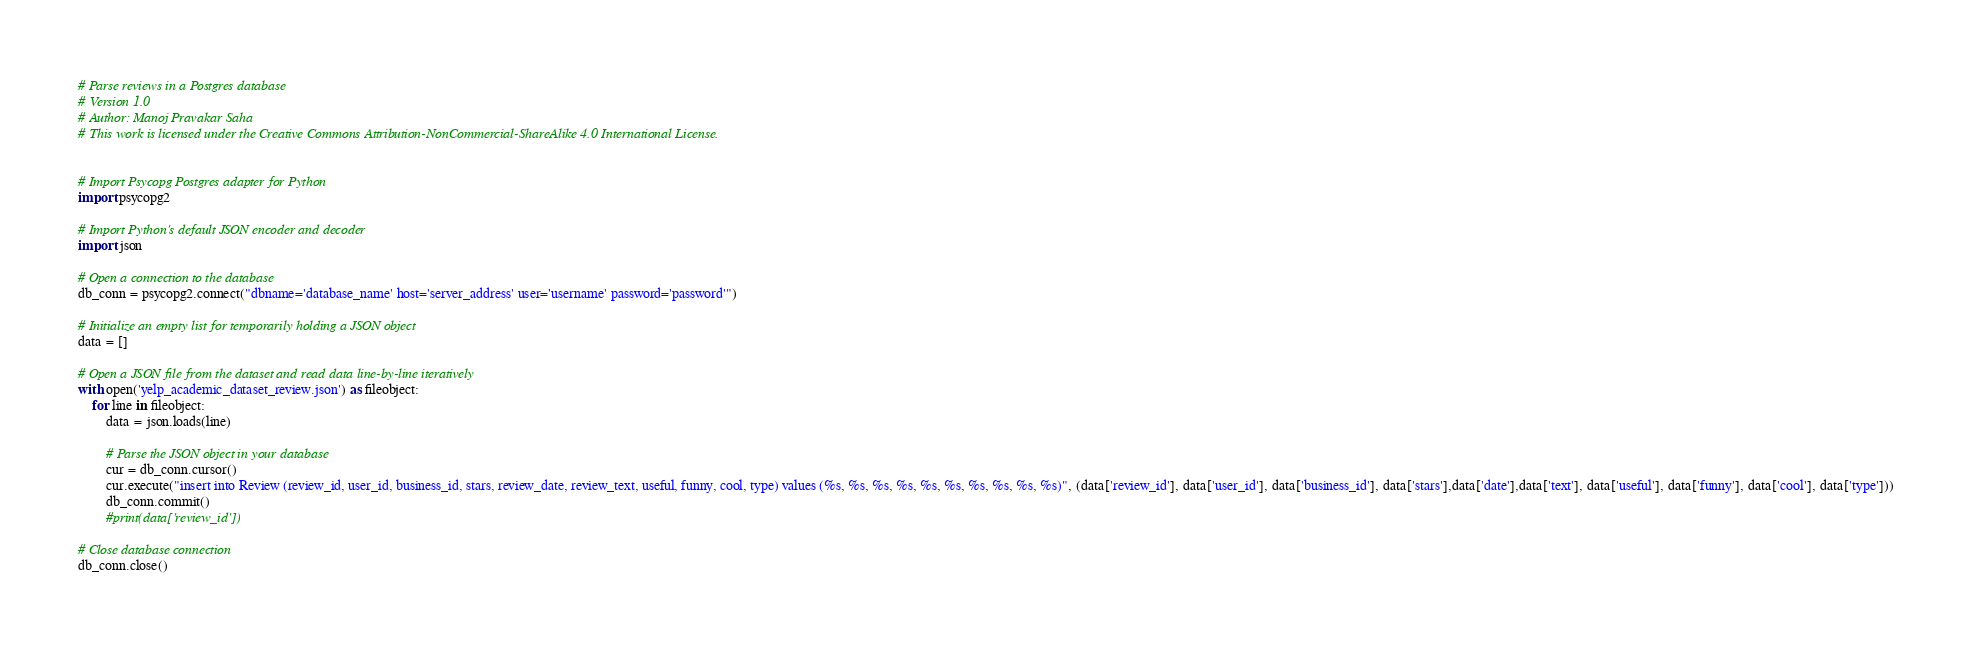<code> <loc_0><loc_0><loc_500><loc_500><_Python_># Parse reviews in a Postgres database
# Version 1.0
# Author: Manoj Pravakar Saha
# This work is licensed under the Creative Commons Attribution-NonCommercial-ShareAlike 4.0 International License.


# Import Psycopg Postgres adapter for Python
import psycopg2

# Import Python's default JSON encoder and decoder
import json

# Open a connection to the database
db_conn = psycopg2.connect("dbname='database_name' host='server_address' user='username' password='password'")

# Initialize an empty list for temporarily holding a JSON object
data = []

# Open a JSON file from the dataset and read data line-by-line iteratively
with open('yelp_academic_dataset_review.json') as fileobject:
	for line in fileobject:
		data = json.loads(line)

		# Parse the JSON object in your database
		cur = db_conn.cursor()
		cur.execute("insert into Review (review_id, user_id, business_id, stars, review_date, review_text, useful, funny, cool, type) values (%s, %s, %s, %s, %s, %s, %s, %s, %s, %s)", (data['review_id'], data['user_id'], data['business_id'], data['stars'],data['date'],data['text'], data['useful'], data['funny'], data['cool'], data['type']))
		db_conn.commit()
		#print(data['review_id'])

# Close database connection
db_conn.close()
</code> 